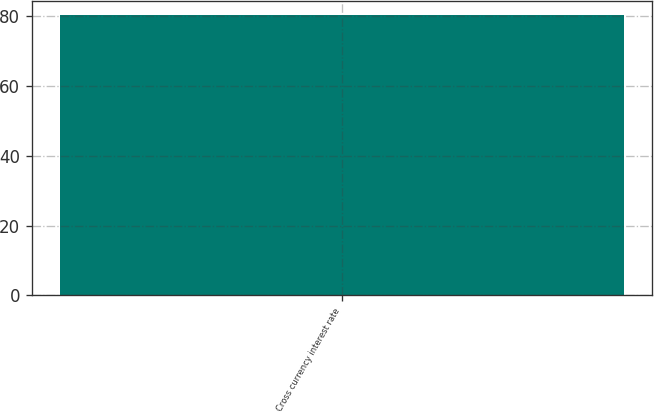Convert chart. <chart><loc_0><loc_0><loc_500><loc_500><bar_chart><fcel>Cross currency interest rate<nl><fcel>80.2<nl></chart> 